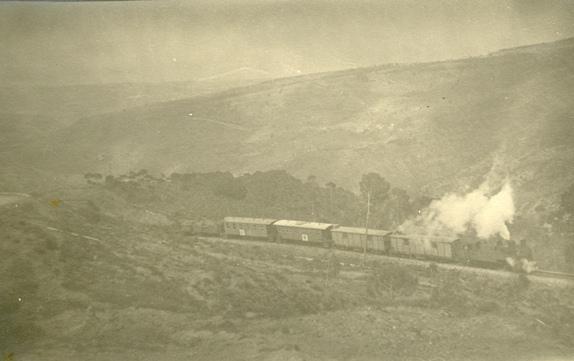Where is the smoke coming from?
Quick response, please. Train. Is the train long?
Be succinct. No. Which direction is the training in this picture going?
Quick response, please. Right. Are there lots of people within this picture?
Answer briefly. No. Is it winter time?
Answer briefly. No. 